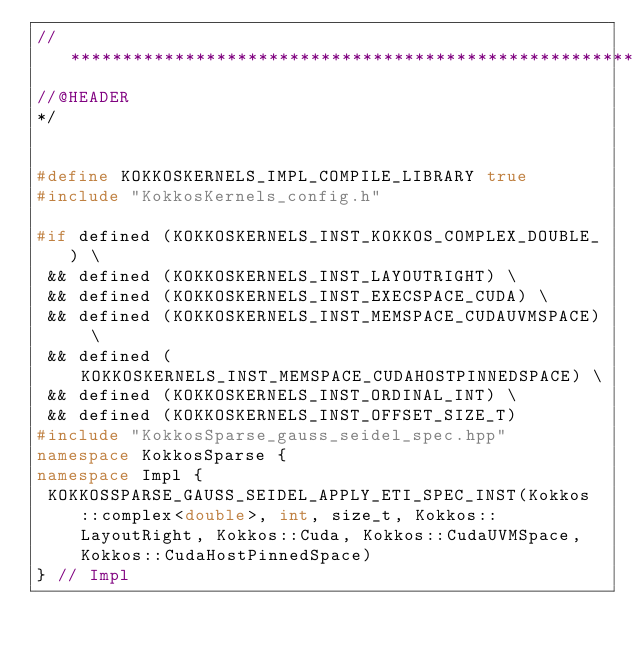<code> <loc_0><loc_0><loc_500><loc_500><_C++_>// ************************************************************************
//@HEADER
*/


#define KOKKOSKERNELS_IMPL_COMPILE_LIBRARY true
#include "KokkosKernels_config.h"

#if defined (KOKKOSKERNELS_INST_KOKKOS_COMPLEX_DOUBLE_) \
 && defined (KOKKOSKERNELS_INST_LAYOUTRIGHT) \
 && defined (KOKKOSKERNELS_INST_EXECSPACE_CUDA) \
 && defined (KOKKOSKERNELS_INST_MEMSPACE_CUDAUVMSPACE) \
 && defined (KOKKOSKERNELS_INST_MEMSPACE_CUDAHOSTPINNEDSPACE) \
 && defined (KOKKOSKERNELS_INST_ORDINAL_INT) \
 && defined (KOKKOSKERNELS_INST_OFFSET_SIZE_T) 
#include "KokkosSparse_gauss_seidel_spec.hpp"
namespace KokkosSparse {
namespace Impl {
 KOKKOSSPARSE_GAUSS_SEIDEL_APPLY_ETI_SPEC_INST(Kokkos::complex<double>, int, size_t, Kokkos::LayoutRight, Kokkos::Cuda, Kokkos::CudaUVMSpace, Kokkos::CudaHostPinnedSpace)
} // Impl</code> 